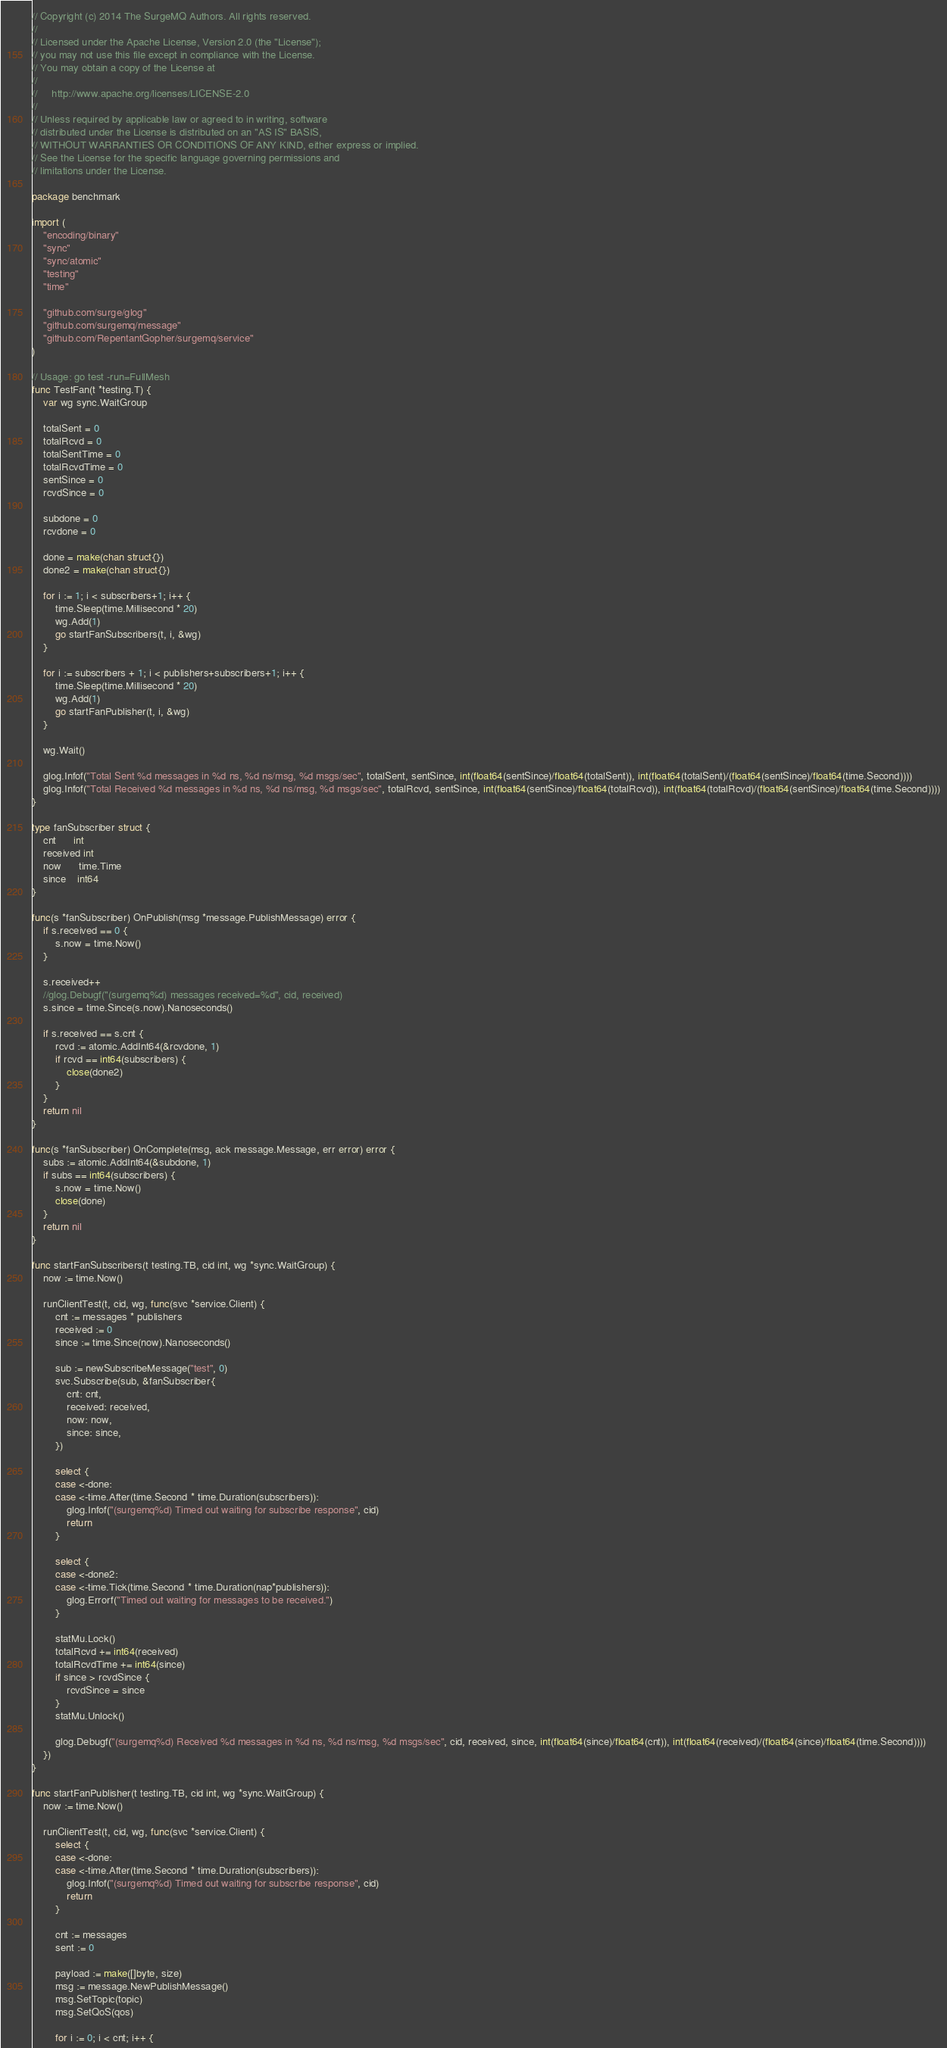<code> <loc_0><loc_0><loc_500><loc_500><_Go_>// Copyright (c) 2014 The SurgeMQ Authors. All rights reserved.
//
// Licensed under the Apache License, Version 2.0 (the "License");
// you may not use this file except in compliance with the License.
// You may obtain a copy of the License at
//
//     http://www.apache.org/licenses/LICENSE-2.0
//
// Unless required by applicable law or agreed to in writing, software
// distributed under the License is distributed on an "AS IS" BASIS,
// WITHOUT WARRANTIES OR CONDITIONS OF ANY KIND, either express or implied.
// See the License for the specific language governing permissions and
// limitations under the License.

package benchmark

import (
	"encoding/binary"
	"sync"
	"sync/atomic"
	"testing"
	"time"

	"github.com/surge/glog"
	"github.com/surgemq/message"
	"github.com/RepentantGopher/surgemq/service"
)

// Usage: go test -run=FullMesh
func TestFan(t *testing.T) {
	var wg sync.WaitGroup

	totalSent = 0
	totalRcvd = 0
	totalSentTime = 0
	totalRcvdTime = 0
	sentSince = 0
	rcvdSince = 0

	subdone = 0
	rcvdone = 0

	done = make(chan struct{})
	done2 = make(chan struct{})

	for i := 1; i < subscribers+1; i++ {
		time.Sleep(time.Millisecond * 20)
		wg.Add(1)
		go startFanSubscribers(t, i, &wg)
	}

	for i := subscribers + 1; i < publishers+subscribers+1; i++ {
		time.Sleep(time.Millisecond * 20)
		wg.Add(1)
		go startFanPublisher(t, i, &wg)
	}

	wg.Wait()

	glog.Infof("Total Sent %d messages in %d ns, %d ns/msg, %d msgs/sec", totalSent, sentSince, int(float64(sentSince)/float64(totalSent)), int(float64(totalSent)/(float64(sentSince)/float64(time.Second))))
	glog.Infof("Total Received %d messages in %d ns, %d ns/msg, %d msgs/sec", totalRcvd, sentSince, int(float64(sentSince)/float64(totalRcvd)), int(float64(totalRcvd)/(float64(sentSince)/float64(time.Second))))
}

type fanSubscriber struct {
	cnt      int
	received int
	now      time.Time
	since    int64
}

func(s *fanSubscriber) OnPublish(msg *message.PublishMessage) error {
	if s.received == 0 {
		s.now = time.Now()
	}

	s.received++
	//glog.Debugf("(surgemq%d) messages received=%d", cid, received)
	s.since = time.Since(s.now).Nanoseconds()

	if s.received == s.cnt {
		rcvd := atomic.AddInt64(&rcvdone, 1)
		if rcvd == int64(subscribers) {
			close(done2)
		}
	}
	return nil
}

func(s *fanSubscriber) OnComplete(msg, ack message.Message, err error) error {
	subs := atomic.AddInt64(&subdone, 1)
	if subs == int64(subscribers) {
		s.now = time.Now()
		close(done)
	}
	return nil
}

func startFanSubscribers(t testing.TB, cid int, wg *sync.WaitGroup) {
	now := time.Now()

	runClientTest(t, cid, wg, func(svc *service.Client) {
		cnt := messages * publishers
		received := 0
		since := time.Since(now).Nanoseconds()

		sub := newSubscribeMessage("test", 0)
		svc.Subscribe(sub, &fanSubscriber{
			cnt: cnt,
			received: received,
			now: now,
			since: since,
		})

		select {
		case <-done:
		case <-time.After(time.Second * time.Duration(subscribers)):
			glog.Infof("(surgemq%d) Timed out waiting for subscribe response", cid)
			return
		}

		select {
		case <-done2:
		case <-time.Tick(time.Second * time.Duration(nap*publishers)):
			glog.Errorf("Timed out waiting for messages to be received.")
		}

		statMu.Lock()
		totalRcvd += int64(received)
		totalRcvdTime += int64(since)
		if since > rcvdSince {
			rcvdSince = since
		}
		statMu.Unlock()

		glog.Debugf("(surgemq%d) Received %d messages in %d ns, %d ns/msg, %d msgs/sec", cid, received, since, int(float64(since)/float64(cnt)), int(float64(received)/(float64(since)/float64(time.Second))))
	})
}

func startFanPublisher(t testing.TB, cid int, wg *sync.WaitGroup) {
	now := time.Now()

	runClientTest(t, cid, wg, func(svc *service.Client) {
		select {
		case <-done:
		case <-time.After(time.Second * time.Duration(subscribers)):
			glog.Infof("(surgemq%d) Timed out waiting for subscribe response", cid)
			return
		}

		cnt := messages
		sent := 0

		payload := make([]byte, size)
		msg := message.NewPublishMessage()
		msg.SetTopic(topic)
		msg.SetQoS(qos)

		for i := 0; i < cnt; i++ {</code> 